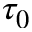Convert formula to latex. <formula><loc_0><loc_0><loc_500><loc_500>\tau _ { 0 }</formula> 